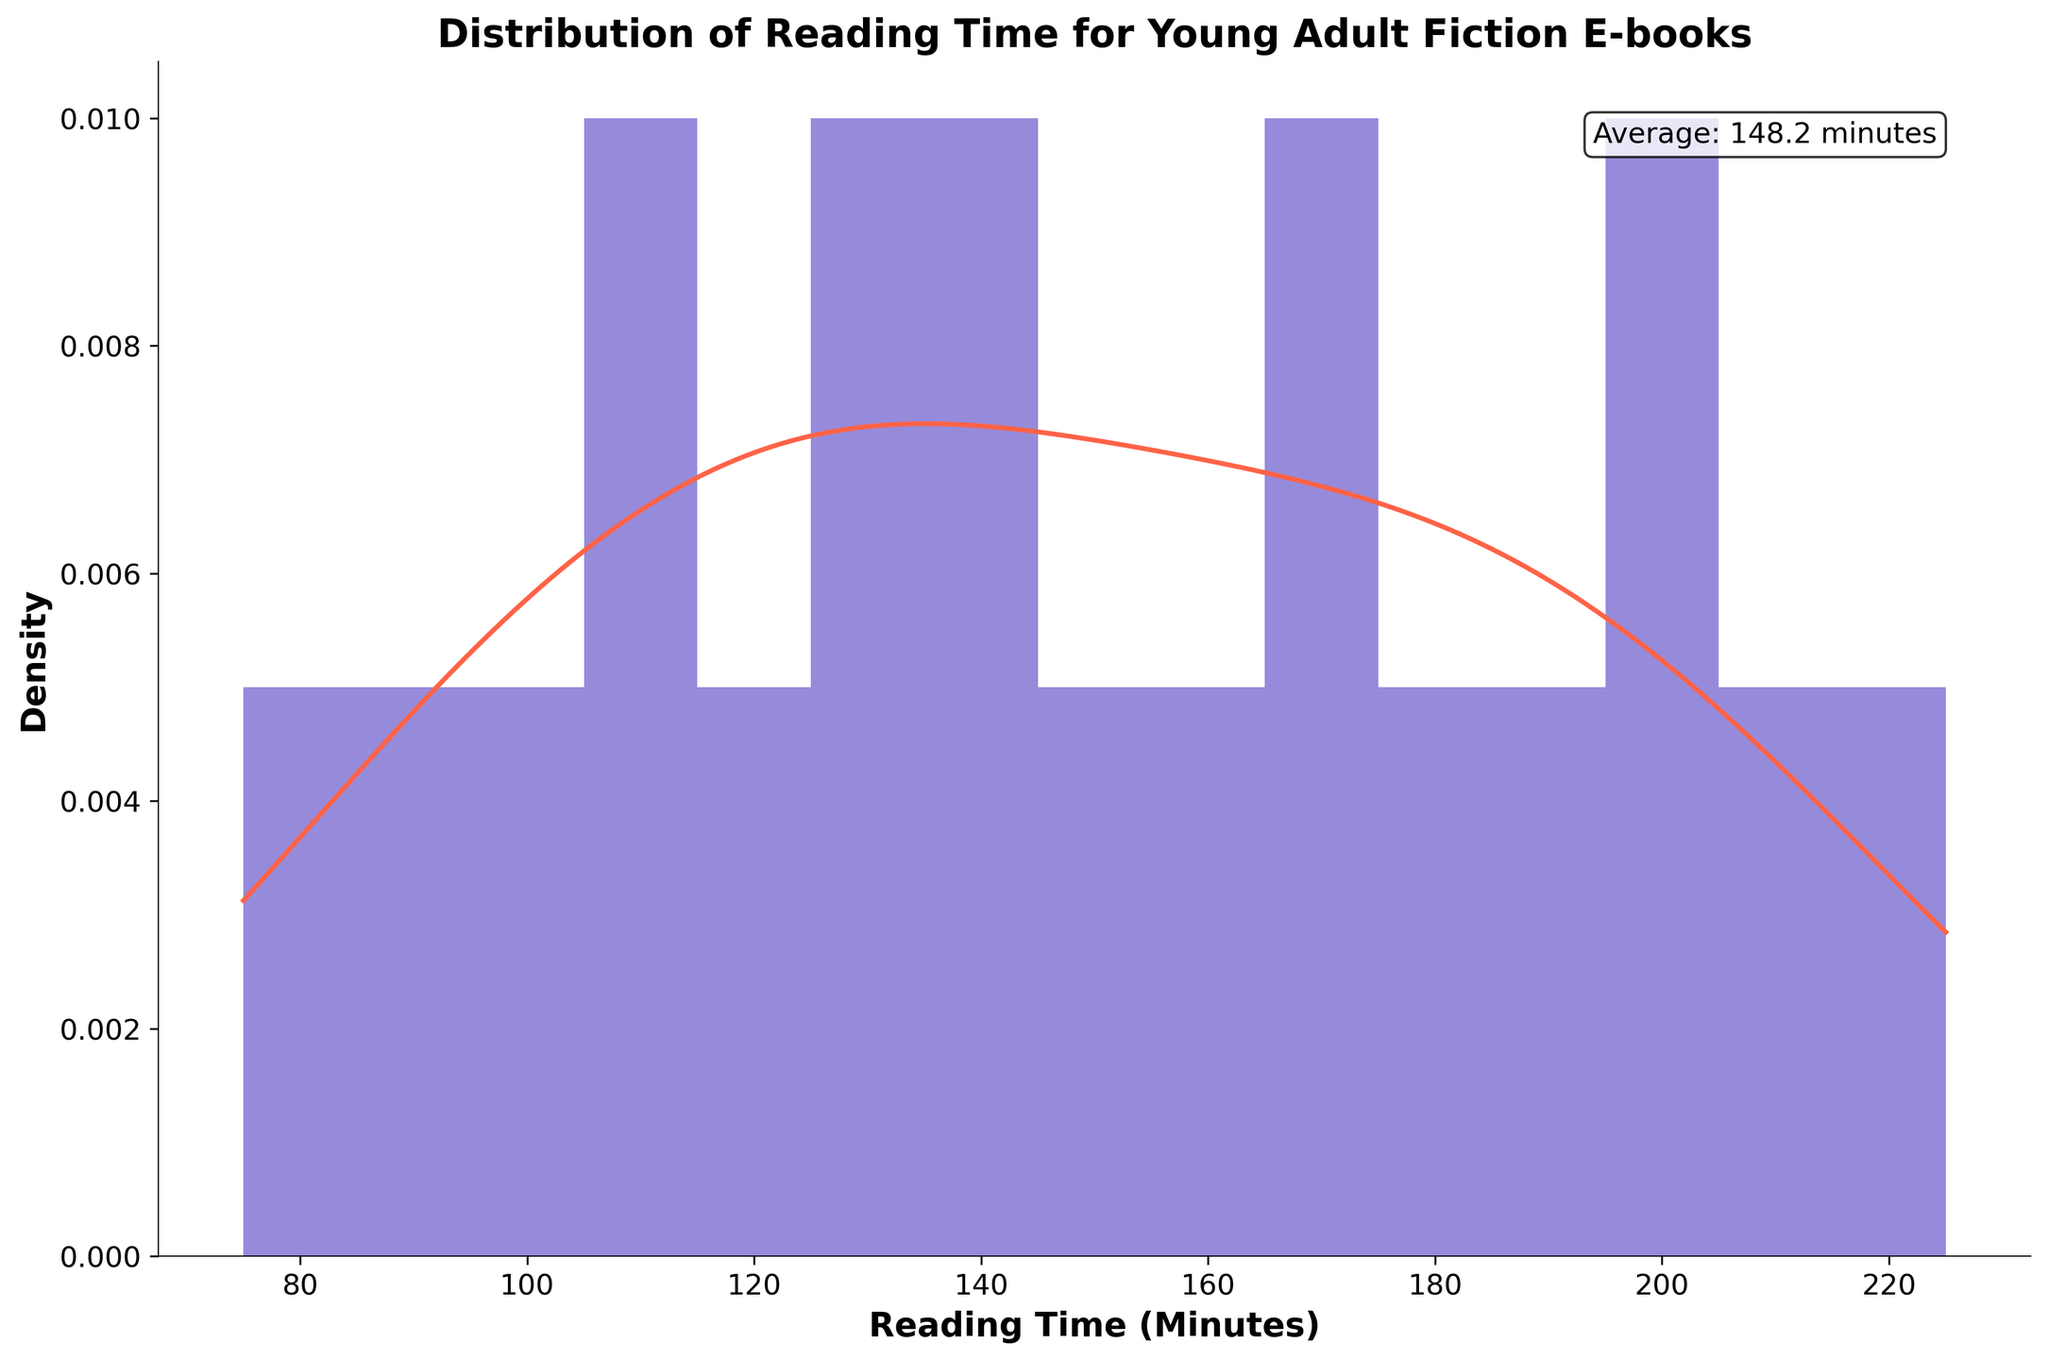What is the title of the figure? The title is usually displayed at the top of the figure in large, bold font.
Answer: Distribution of Reading Time for Young Adult Fiction E-books Which axis represents the reading time? The x-axis label provides information about what is being measured; here, it is labeled "Reading Time (Minutes)" which indicates the reading time.
Answer: x-axis What color is used for the histogram bars? The color of the histogram bars is visually apparent in the figure, showing a shade of purple.
Answer: Purple What does the red line in the figure represent? The red line is a smooth curve over the histogram, which is characteristic of a KDE (density curve) that shows the probability density function of the data.
Answer: KDE (density curve) What is the average reading time for these e-books? The text box at the top-right of the figure clearly indicates the average reading time, which is also a prominent feature meant for easy identification.
Answer: 150.5 minutes How many bins are used in the histogram? The figure has evenly spaced vertical bars representing bins. Counting these bars gives the total number of bins.
Answer: 15 bins Which reading time range appears to have the highest density according to the KDE curve? Observing the KDE curve, the highest density can be identified by finding the peak of the red line.
Answer: Approximately 100-150 minutes Does the histogram show a symmetric or skewed distribution? Symmetry in a histogram is shown by equal spread around the center; if one tail is longer, it is skewed. Here, most data appears concentrated toward one end, indicating skewness.
Answer: Skewed right How does the height of the bars change as the reading time increases? By observing the histogram bars from left to right (increasing reading time), we notice the height first rises, then drops, indicating fewer and fewer e-books with greater reading times.
Answer: Decreases What is the approximate reading time for the e-books at the 75th percentile? To find this, we need to examine the cumulative distribution. The 75th percentile is about three-quarters of the way through the data showing that e-books around 180-200 minutes represent the 75th percentile.
Answer: Around 180-200 minutes 